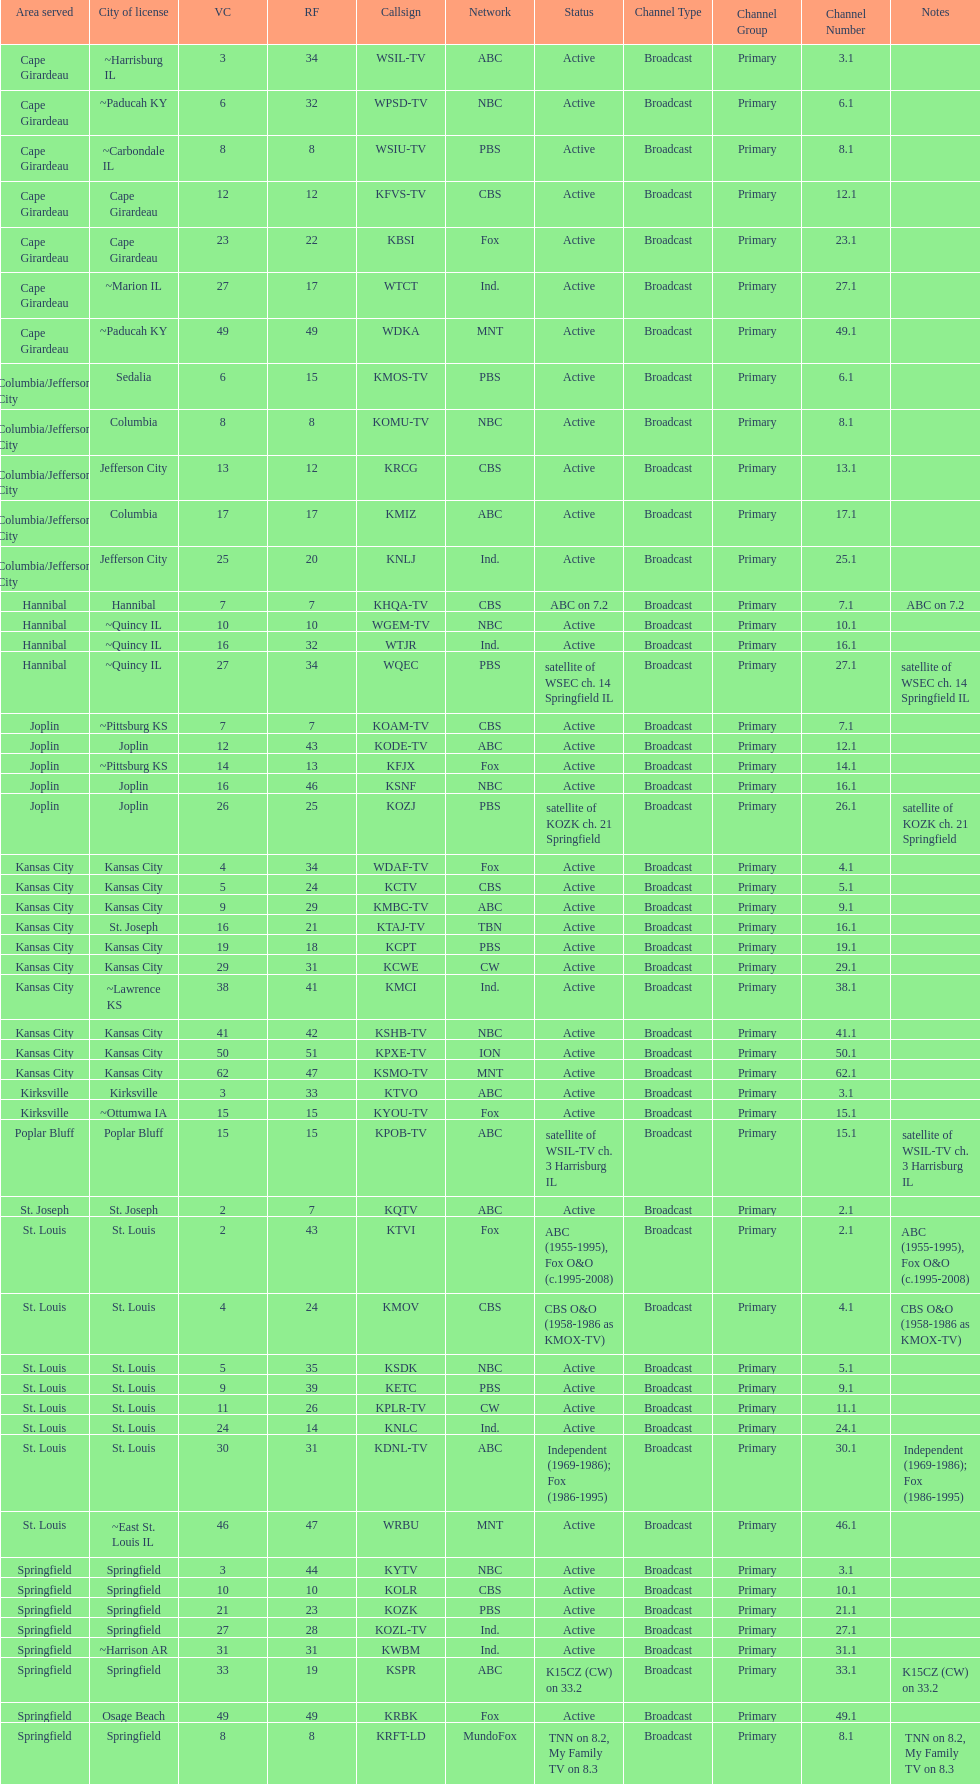What is the total number of stations under the cbs network? 7. 